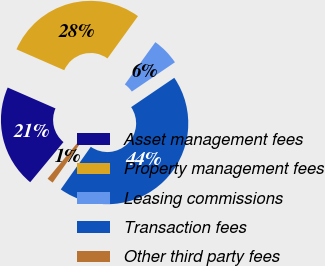<chart> <loc_0><loc_0><loc_500><loc_500><pie_chart><fcel>Asset management fees<fcel>Property management fees<fcel>Leasing commissions<fcel>Transaction fees<fcel>Other third party fees<nl><fcel>20.54%<fcel>28.39%<fcel>5.55%<fcel>44.27%<fcel>1.25%<nl></chart> 